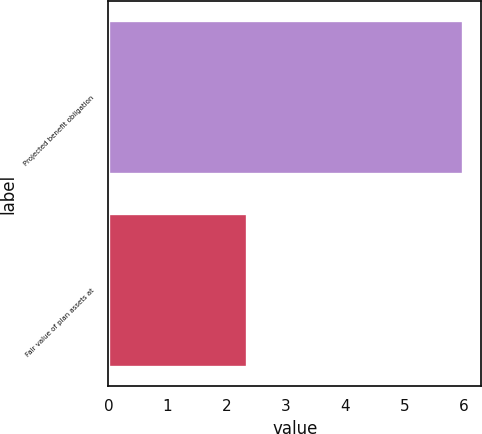<chart> <loc_0><loc_0><loc_500><loc_500><bar_chart><fcel>Projected benefit obligation<fcel>Fair value of plan assets at<nl><fcel>6<fcel>2.35<nl></chart> 